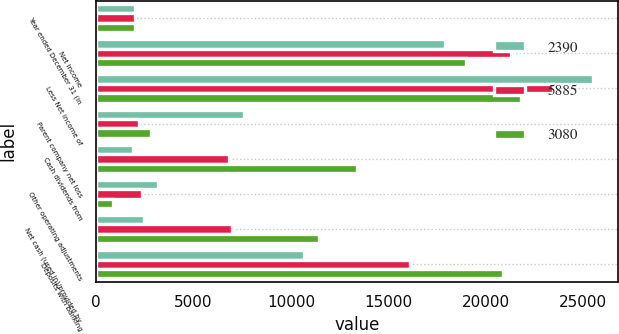<chart> <loc_0><loc_0><loc_500><loc_500><stacked_bar_chart><ecel><fcel>Year ended December 31 (in<fcel>Net income<fcel>Less Net income of<fcel>Parent company net loss<fcel>Cash dividends from<fcel>Other operating adjustments<fcel>Net cash (used in)/provided by<fcel>Deposits with banking<nl><fcel>2390<fcel>2013<fcel>17923<fcel>25496<fcel>7573<fcel>1917<fcel>3180<fcel>2476<fcel>10679<nl><fcel>5885<fcel>2012<fcel>21284<fcel>23474<fcel>2190<fcel>6798<fcel>2376<fcel>6984<fcel>16100<nl><fcel>3080<fcel>2011<fcel>18976<fcel>21805<fcel>2829<fcel>13414<fcel>860<fcel>11445<fcel>20866<nl></chart> 